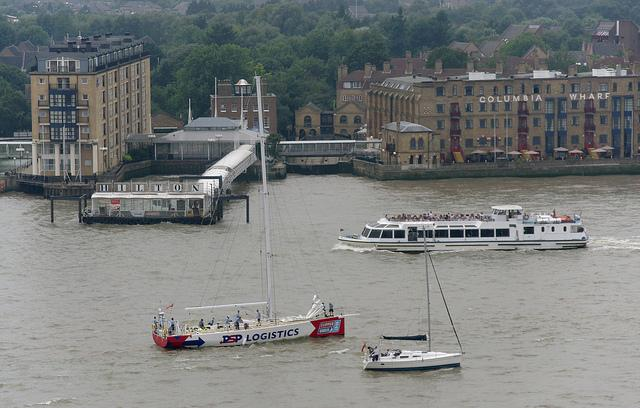In what country is this river in? Please explain your reasoning. britain. The sign says columbia wharf. 